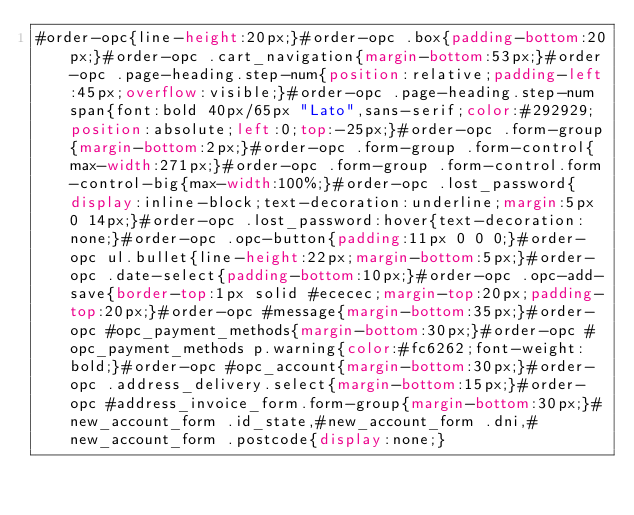Convert code to text. <code><loc_0><loc_0><loc_500><loc_500><_CSS_>#order-opc{line-height:20px;}#order-opc .box{padding-bottom:20px;}#order-opc .cart_navigation{margin-bottom:53px;}#order-opc .page-heading.step-num{position:relative;padding-left:45px;overflow:visible;}#order-opc .page-heading.step-num span{font:bold 40px/65px "Lato",sans-serif;color:#292929;position:absolute;left:0;top:-25px;}#order-opc .form-group{margin-bottom:2px;}#order-opc .form-group .form-control{max-width:271px;}#order-opc .form-group .form-control.form-control-big{max-width:100%;}#order-opc .lost_password{display:inline-block;text-decoration:underline;margin:5px 0 14px;}#order-opc .lost_password:hover{text-decoration:none;}#order-opc .opc-button{padding:11px 0 0 0;}#order-opc ul.bullet{line-height:22px;margin-bottom:5px;}#order-opc .date-select{padding-bottom:10px;}#order-opc .opc-add-save{border-top:1px solid #ececec;margin-top:20px;padding-top:20px;}#order-opc #message{margin-bottom:35px;}#order-opc #opc_payment_methods{margin-bottom:30px;}#order-opc #opc_payment_methods p.warning{color:#fc6262;font-weight:bold;}#order-opc #opc_account{margin-bottom:30px;}#order-opc .address_delivery.select{margin-bottom:15px;}#order-opc #address_invoice_form.form-group{margin-bottom:30px;}#new_account_form .id_state,#new_account_form .dni,#new_account_form .postcode{display:none;}</code> 